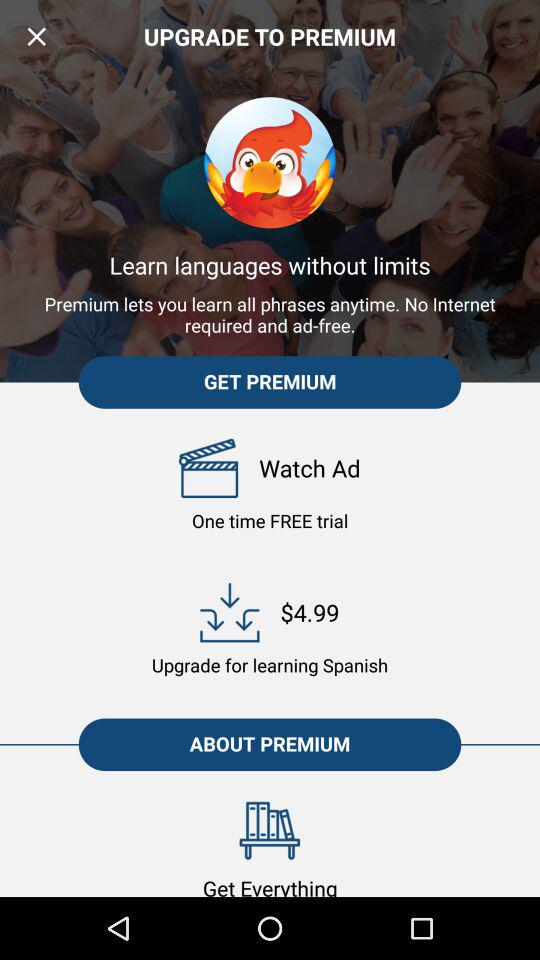How much money do I have to pay to upgrade to learn Spanish? You have to pay $4.99. 